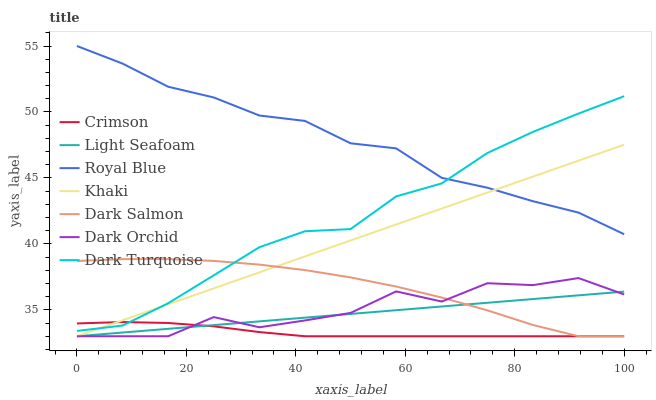Does Crimson have the minimum area under the curve?
Answer yes or no. Yes. Does Royal Blue have the maximum area under the curve?
Answer yes or no. Yes. Does Dark Turquoise have the minimum area under the curve?
Answer yes or no. No. Does Dark Turquoise have the maximum area under the curve?
Answer yes or no. No. Is Khaki the smoothest?
Answer yes or no. Yes. Is Dark Orchid the roughest?
Answer yes or no. Yes. Is Dark Turquoise the smoothest?
Answer yes or no. No. Is Dark Turquoise the roughest?
Answer yes or no. No. Does Khaki have the lowest value?
Answer yes or no. Yes. Does Dark Turquoise have the lowest value?
Answer yes or no. No. Does Royal Blue have the highest value?
Answer yes or no. Yes. Does Dark Turquoise have the highest value?
Answer yes or no. No. Is Light Seafoam less than Dark Turquoise?
Answer yes or no. Yes. Is Royal Blue greater than Dark Salmon?
Answer yes or no. Yes. Does Crimson intersect Khaki?
Answer yes or no. Yes. Is Crimson less than Khaki?
Answer yes or no. No. Is Crimson greater than Khaki?
Answer yes or no. No. Does Light Seafoam intersect Dark Turquoise?
Answer yes or no. No. 